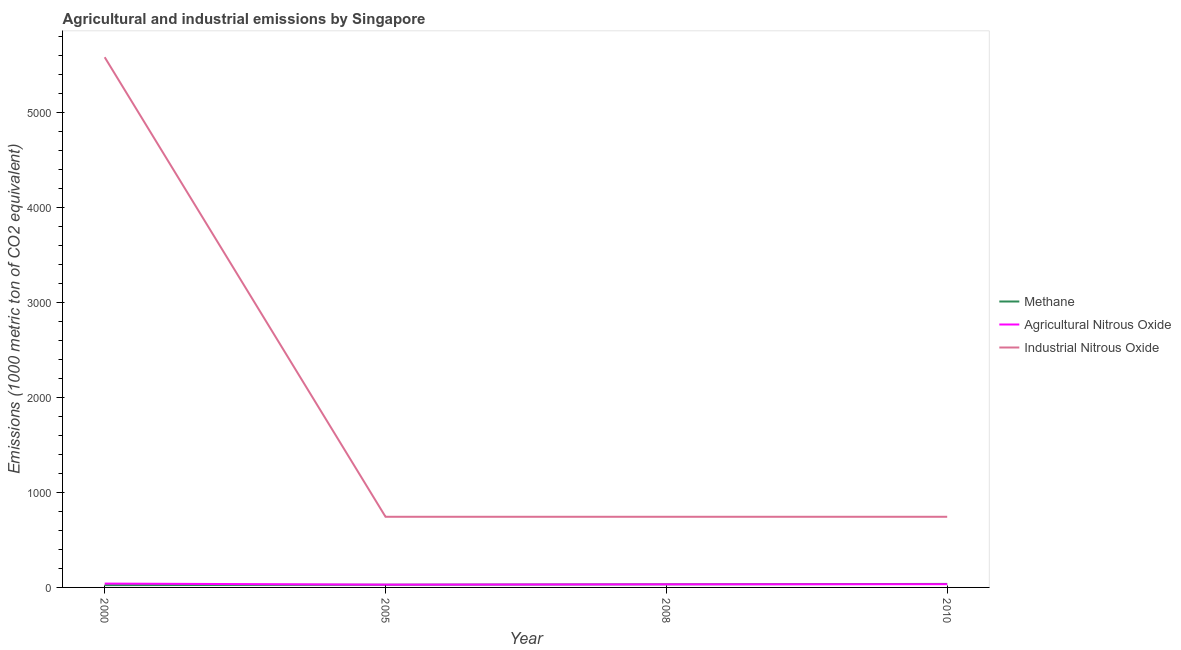Is the number of lines equal to the number of legend labels?
Your answer should be very brief. Yes. What is the amount of methane emissions in 2005?
Give a very brief answer. 28.4. Across all years, what is the maximum amount of methane emissions?
Provide a succinct answer. 36.9. Across all years, what is the minimum amount of industrial nitrous oxide emissions?
Ensure brevity in your answer.  743.5. What is the total amount of agricultural nitrous oxide emissions in the graph?
Provide a succinct answer. 136.7. What is the difference between the amount of industrial nitrous oxide emissions in 2005 and the amount of methane emissions in 2000?
Provide a short and direct response. 719.1. What is the average amount of industrial nitrous oxide emissions per year?
Provide a short and direct response. 1952.62. In the year 2000, what is the difference between the amount of industrial nitrous oxide emissions and amount of agricultural nitrous oxide emissions?
Offer a terse response. 5539.5. What is the ratio of the amount of industrial nitrous oxide emissions in 2005 to that in 2010?
Your response must be concise. 1. Is the amount of agricultural nitrous oxide emissions in 2008 less than that in 2010?
Provide a short and direct response. Yes. What is the difference between the highest and the second highest amount of methane emissions?
Provide a succinct answer. 4.1. What is the difference between the highest and the lowest amount of industrial nitrous oxide emissions?
Your response must be concise. 4836.5. Is the sum of the amount of methane emissions in 2005 and 2010 greater than the maximum amount of industrial nitrous oxide emissions across all years?
Your response must be concise. No. How many lines are there?
Your answer should be very brief. 3. How many years are there in the graph?
Your answer should be very brief. 4. Are the values on the major ticks of Y-axis written in scientific E-notation?
Ensure brevity in your answer.  No. How are the legend labels stacked?
Offer a terse response. Vertical. What is the title of the graph?
Give a very brief answer. Agricultural and industrial emissions by Singapore. Does "Liquid fuel" appear as one of the legend labels in the graph?
Your answer should be compact. No. What is the label or title of the Y-axis?
Provide a short and direct response. Emissions (1000 metric ton of CO2 equivalent). What is the Emissions (1000 metric ton of CO2 equivalent) in Methane in 2000?
Make the answer very short. 24.4. What is the Emissions (1000 metric ton of CO2 equivalent) of Agricultural Nitrous Oxide in 2000?
Give a very brief answer. 40.5. What is the Emissions (1000 metric ton of CO2 equivalent) in Industrial Nitrous Oxide in 2000?
Your response must be concise. 5580. What is the Emissions (1000 metric ton of CO2 equivalent) of Methane in 2005?
Your answer should be compact. 28.4. What is the Emissions (1000 metric ton of CO2 equivalent) of Agricultural Nitrous Oxide in 2005?
Your response must be concise. 29.5. What is the Emissions (1000 metric ton of CO2 equivalent) in Industrial Nitrous Oxide in 2005?
Offer a terse response. 743.5. What is the Emissions (1000 metric ton of CO2 equivalent) in Methane in 2008?
Ensure brevity in your answer.  32.8. What is the Emissions (1000 metric ton of CO2 equivalent) in Agricultural Nitrous Oxide in 2008?
Your answer should be compact. 32.6. What is the Emissions (1000 metric ton of CO2 equivalent) in Industrial Nitrous Oxide in 2008?
Offer a very short reply. 743.5. What is the Emissions (1000 metric ton of CO2 equivalent) of Methane in 2010?
Keep it short and to the point. 36.9. What is the Emissions (1000 metric ton of CO2 equivalent) of Agricultural Nitrous Oxide in 2010?
Offer a very short reply. 34.1. What is the Emissions (1000 metric ton of CO2 equivalent) of Industrial Nitrous Oxide in 2010?
Your answer should be very brief. 743.5. Across all years, what is the maximum Emissions (1000 metric ton of CO2 equivalent) of Methane?
Provide a succinct answer. 36.9. Across all years, what is the maximum Emissions (1000 metric ton of CO2 equivalent) in Agricultural Nitrous Oxide?
Give a very brief answer. 40.5. Across all years, what is the maximum Emissions (1000 metric ton of CO2 equivalent) in Industrial Nitrous Oxide?
Your response must be concise. 5580. Across all years, what is the minimum Emissions (1000 metric ton of CO2 equivalent) of Methane?
Offer a terse response. 24.4. Across all years, what is the minimum Emissions (1000 metric ton of CO2 equivalent) in Agricultural Nitrous Oxide?
Provide a short and direct response. 29.5. Across all years, what is the minimum Emissions (1000 metric ton of CO2 equivalent) of Industrial Nitrous Oxide?
Your answer should be compact. 743.5. What is the total Emissions (1000 metric ton of CO2 equivalent) of Methane in the graph?
Offer a very short reply. 122.5. What is the total Emissions (1000 metric ton of CO2 equivalent) in Agricultural Nitrous Oxide in the graph?
Your answer should be very brief. 136.7. What is the total Emissions (1000 metric ton of CO2 equivalent) in Industrial Nitrous Oxide in the graph?
Offer a terse response. 7810.5. What is the difference between the Emissions (1000 metric ton of CO2 equivalent) of Methane in 2000 and that in 2005?
Your response must be concise. -4. What is the difference between the Emissions (1000 metric ton of CO2 equivalent) of Industrial Nitrous Oxide in 2000 and that in 2005?
Ensure brevity in your answer.  4836.5. What is the difference between the Emissions (1000 metric ton of CO2 equivalent) of Industrial Nitrous Oxide in 2000 and that in 2008?
Offer a terse response. 4836.5. What is the difference between the Emissions (1000 metric ton of CO2 equivalent) of Methane in 2000 and that in 2010?
Keep it short and to the point. -12.5. What is the difference between the Emissions (1000 metric ton of CO2 equivalent) in Industrial Nitrous Oxide in 2000 and that in 2010?
Your answer should be compact. 4836.5. What is the difference between the Emissions (1000 metric ton of CO2 equivalent) in Industrial Nitrous Oxide in 2005 and that in 2008?
Your answer should be compact. 0. What is the difference between the Emissions (1000 metric ton of CO2 equivalent) of Methane in 2000 and the Emissions (1000 metric ton of CO2 equivalent) of Industrial Nitrous Oxide in 2005?
Your answer should be very brief. -719.1. What is the difference between the Emissions (1000 metric ton of CO2 equivalent) of Agricultural Nitrous Oxide in 2000 and the Emissions (1000 metric ton of CO2 equivalent) of Industrial Nitrous Oxide in 2005?
Your response must be concise. -703. What is the difference between the Emissions (1000 metric ton of CO2 equivalent) of Methane in 2000 and the Emissions (1000 metric ton of CO2 equivalent) of Industrial Nitrous Oxide in 2008?
Provide a succinct answer. -719.1. What is the difference between the Emissions (1000 metric ton of CO2 equivalent) of Agricultural Nitrous Oxide in 2000 and the Emissions (1000 metric ton of CO2 equivalent) of Industrial Nitrous Oxide in 2008?
Make the answer very short. -703. What is the difference between the Emissions (1000 metric ton of CO2 equivalent) of Methane in 2000 and the Emissions (1000 metric ton of CO2 equivalent) of Industrial Nitrous Oxide in 2010?
Provide a succinct answer. -719.1. What is the difference between the Emissions (1000 metric ton of CO2 equivalent) of Agricultural Nitrous Oxide in 2000 and the Emissions (1000 metric ton of CO2 equivalent) of Industrial Nitrous Oxide in 2010?
Give a very brief answer. -703. What is the difference between the Emissions (1000 metric ton of CO2 equivalent) of Methane in 2005 and the Emissions (1000 metric ton of CO2 equivalent) of Industrial Nitrous Oxide in 2008?
Your answer should be very brief. -715.1. What is the difference between the Emissions (1000 metric ton of CO2 equivalent) in Agricultural Nitrous Oxide in 2005 and the Emissions (1000 metric ton of CO2 equivalent) in Industrial Nitrous Oxide in 2008?
Offer a very short reply. -714. What is the difference between the Emissions (1000 metric ton of CO2 equivalent) of Methane in 2005 and the Emissions (1000 metric ton of CO2 equivalent) of Agricultural Nitrous Oxide in 2010?
Your answer should be very brief. -5.7. What is the difference between the Emissions (1000 metric ton of CO2 equivalent) in Methane in 2005 and the Emissions (1000 metric ton of CO2 equivalent) in Industrial Nitrous Oxide in 2010?
Ensure brevity in your answer.  -715.1. What is the difference between the Emissions (1000 metric ton of CO2 equivalent) in Agricultural Nitrous Oxide in 2005 and the Emissions (1000 metric ton of CO2 equivalent) in Industrial Nitrous Oxide in 2010?
Your response must be concise. -714. What is the difference between the Emissions (1000 metric ton of CO2 equivalent) of Methane in 2008 and the Emissions (1000 metric ton of CO2 equivalent) of Industrial Nitrous Oxide in 2010?
Your response must be concise. -710.7. What is the difference between the Emissions (1000 metric ton of CO2 equivalent) of Agricultural Nitrous Oxide in 2008 and the Emissions (1000 metric ton of CO2 equivalent) of Industrial Nitrous Oxide in 2010?
Offer a very short reply. -710.9. What is the average Emissions (1000 metric ton of CO2 equivalent) of Methane per year?
Make the answer very short. 30.62. What is the average Emissions (1000 metric ton of CO2 equivalent) in Agricultural Nitrous Oxide per year?
Keep it short and to the point. 34.17. What is the average Emissions (1000 metric ton of CO2 equivalent) in Industrial Nitrous Oxide per year?
Your answer should be very brief. 1952.62. In the year 2000, what is the difference between the Emissions (1000 metric ton of CO2 equivalent) of Methane and Emissions (1000 metric ton of CO2 equivalent) of Agricultural Nitrous Oxide?
Make the answer very short. -16.1. In the year 2000, what is the difference between the Emissions (1000 metric ton of CO2 equivalent) in Methane and Emissions (1000 metric ton of CO2 equivalent) in Industrial Nitrous Oxide?
Make the answer very short. -5555.6. In the year 2000, what is the difference between the Emissions (1000 metric ton of CO2 equivalent) of Agricultural Nitrous Oxide and Emissions (1000 metric ton of CO2 equivalent) of Industrial Nitrous Oxide?
Your answer should be very brief. -5539.5. In the year 2005, what is the difference between the Emissions (1000 metric ton of CO2 equivalent) of Methane and Emissions (1000 metric ton of CO2 equivalent) of Industrial Nitrous Oxide?
Your answer should be compact. -715.1. In the year 2005, what is the difference between the Emissions (1000 metric ton of CO2 equivalent) of Agricultural Nitrous Oxide and Emissions (1000 metric ton of CO2 equivalent) of Industrial Nitrous Oxide?
Your answer should be very brief. -714. In the year 2008, what is the difference between the Emissions (1000 metric ton of CO2 equivalent) of Methane and Emissions (1000 metric ton of CO2 equivalent) of Industrial Nitrous Oxide?
Provide a short and direct response. -710.7. In the year 2008, what is the difference between the Emissions (1000 metric ton of CO2 equivalent) of Agricultural Nitrous Oxide and Emissions (1000 metric ton of CO2 equivalent) of Industrial Nitrous Oxide?
Your response must be concise. -710.9. In the year 2010, what is the difference between the Emissions (1000 metric ton of CO2 equivalent) of Methane and Emissions (1000 metric ton of CO2 equivalent) of Industrial Nitrous Oxide?
Offer a very short reply. -706.6. In the year 2010, what is the difference between the Emissions (1000 metric ton of CO2 equivalent) of Agricultural Nitrous Oxide and Emissions (1000 metric ton of CO2 equivalent) of Industrial Nitrous Oxide?
Your response must be concise. -709.4. What is the ratio of the Emissions (1000 metric ton of CO2 equivalent) in Methane in 2000 to that in 2005?
Your answer should be very brief. 0.86. What is the ratio of the Emissions (1000 metric ton of CO2 equivalent) in Agricultural Nitrous Oxide in 2000 to that in 2005?
Make the answer very short. 1.37. What is the ratio of the Emissions (1000 metric ton of CO2 equivalent) in Industrial Nitrous Oxide in 2000 to that in 2005?
Provide a succinct answer. 7.5. What is the ratio of the Emissions (1000 metric ton of CO2 equivalent) of Methane in 2000 to that in 2008?
Offer a terse response. 0.74. What is the ratio of the Emissions (1000 metric ton of CO2 equivalent) of Agricultural Nitrous Oxide in 2000 to that in 2008?
Keep it short and to the point. 1.24. What is the ratio of the Emissions (1000 metric ton of CO2 equivalent) of Industrial Nitrous Oxide in 2000 to that in 2008?
Offer a very short reply. 7.5. What is the ratio of the Emissions (1000 metric ton of CO2 equivalent) of Methane in 2000 to that in 2010?
Your answer should be very brief. 0.66. What is the ratio of the Emissions (1000 metric ton of CO2 equivalent) of Agricultural Nitrous Oxide in 2000 to that in 2010?
Provide a short and direct response. 1.19. What is the ratio of the Emissions (1000 metric ton of CO2 equivalent) of Industrial Nitrous Oxide in 2000 to that in 2010?
Your answer should be very brief. 7.5. What is the ratio of the Emissions (1000 metric ton of CO2 equivalent) in Methane in 2005 to that in 2008?
Offer a terse response. 0.87. What is the ratio of the Emissions (1000 metric ton of CO2 equivalent) in Agricultural Nitrous Oxide in 2005 to that in 2008?
Make the answer very short. 0.9. What is the ratio of the Emissions (1000 metric ton of CO2 equivalent) of Industrial Nitrous Oxide in 2005 to that in 2008?
Your response must be concise. 1. What is the ratio of the Emissions (1000 metric ton of CO2 equivalent) in Methane in 2005 to that in 2010?
Keep it short and to the point. 0.77. What is the ratio of the Emissions (1000 metric ton of CO2 equivalent) in Agricultural Nitrous Oxide in 2005 to that in 2010?
Ensure brevity in your answer.  0.87. What is the ratio of the Emissions (1000 metric ton of CO2 equivalent) of Industrial Nitrous Oxide in 2005 to that in 2010?
Your answer should be compact. 1. What is the ratio of the Emissions (1000 metric ton of CO2 equivalent) of Methane in 2008 to that in 2010?
Your response must be concise. 0.89. What is the ratio of the Emissions (1000 metric ton of CO2 equivalent) in Agricultural Nitrous Oxide in 2008 to that in 2010?
Keep it short and to the point. 0.96. What is the ratio of the Emissions (1000 metric ton of CO2 equivalent) of Industrial Nitrous Oxide in 2008 to that in 2010?
Your response must be concise. 1. What is the difference between the highest and the second highest Emissions (1000 metric ton of CO2 equivalent) of Methane?
Offer a terse response. 4.1. What is the difference between the highest and the second highest Emissions (1000 metric ton of CO2 equivalent) of Industrial Nitrous Oxide?
Provide a short and direct response. 4836.5. What is the difference between the highest and the lowest Emissions (1000 metric ton of CO2 equivalent) of Industrial Nitrous Oxide?
Provide a succinct answer. 4836.5. 